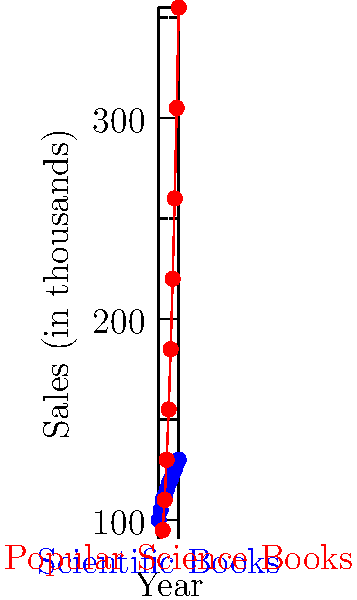Based on the line graph showing sales trends of scientific books and popular science books from 2010 to 2020, what key observation can be made about the relative growth rates of these two categories, and how might this inform publishing strategies for a wide audience? To answer this question, let's analyze the graph step-by-step:

1. Identify the lines:
   - Blue line represents scientific books
   - Red line represents popular science books

2. Observe the starting points (2010):
   - Scientific books: ~100,000 sales
   - Popular science books: ~80,000 sales

3. Observe the ending points (2020):
   - Scientific books: ~130,000 sales
   - Popular science books: ~355,000 sales

4. Calculate growth rates:
   - Scientific books: (130,000 - 100,000) / 100,000 = 30% growth over 10 years
   - Popular science books: (355,000 - 80,000) / 80,000 = 343.75% growth over 10 years

5. Compare growth patterns:
   - Scientific books show steady but slow growth
   - Popular science books demonstrate exponential growth, especially after 2013

6. Publishing strategy implications:
   - The much higher growth rate of popular science books suggests a wider audience appeal
   - There's a clear trend towards more accessible scientific content for general readers
   - Publishers might consider adapting scientific content for a broader audience to capitalize on this trend

The key observation is that popular science books have experienced significantly higher growth rates compared to traditional scientific books, indicating a shift in reader preferences towards more accessible scientific content.
Answer: Popular science books show exponential growth compared to steady growth of scientific books, suggesting a shift towards more accessible scientific content for a wider audience. 